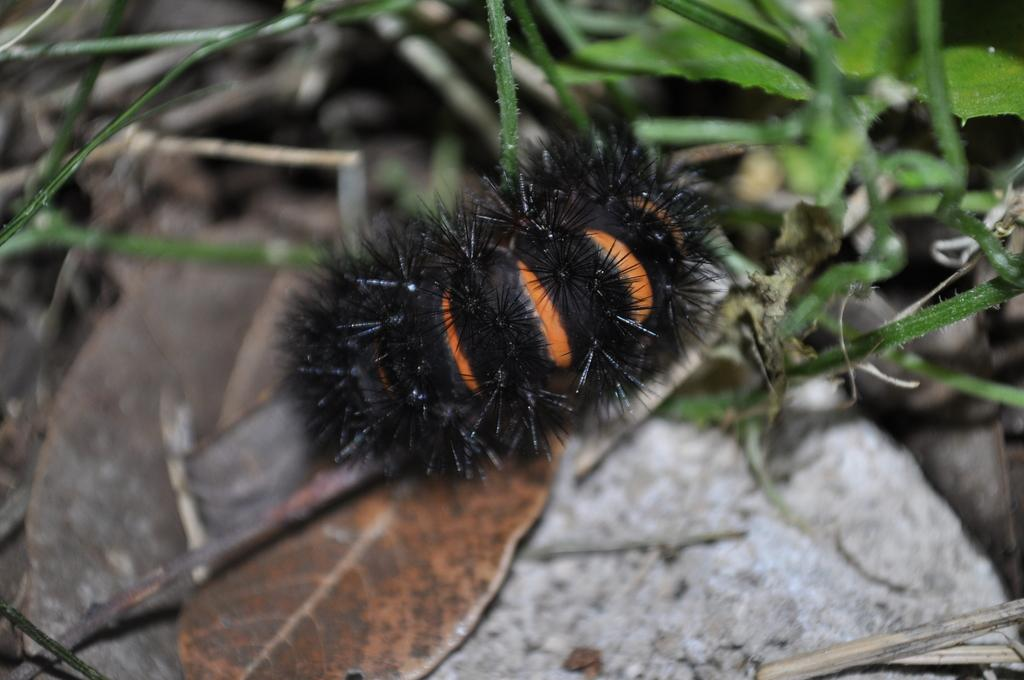What is placed on the rock in the image? There is an insert on a rock in the image. What type of vegetation is near the rock in the image? There are plants near the rock in the image. Can you tell me how many girls are holding celery in the image? There are no girls or celery present in the image. What rule is being enforced in the image? There is no rule being enforced in the image; it features an insert on a rock and plants near the rock. 